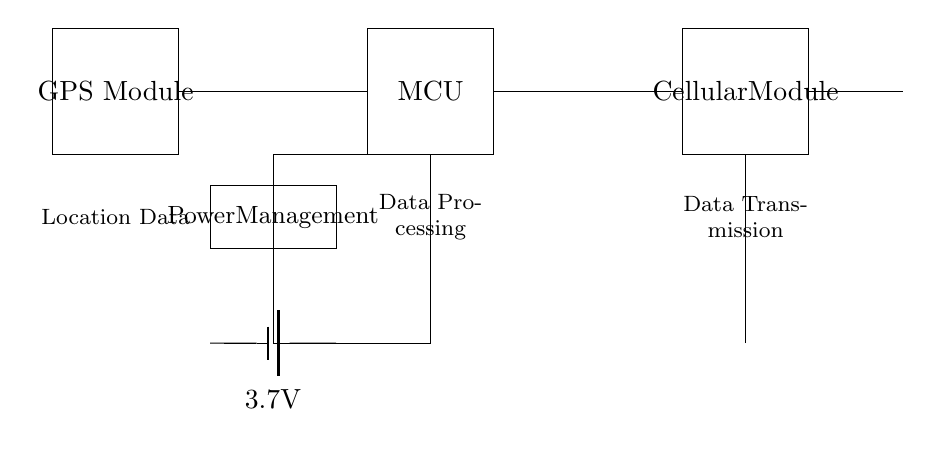What is the main purpose of the GPS module? The GPS module is responsible for acquiring location data by receiving signals from satellites, which allows it to determine the device's geographical position.
Answer: Location data What voltage does the battery supply? The battery is labeled with a voltage of 3.7 volts, indicating the potential difference it provides to the circuit.
Answer: 3.7 volts How many main components are in the diagram? There are four main components shown in the circuit: the GPS module, microcontroller, cellular module, and power management system.
Answer: Four What role does the microcontroller play in this circuit? The microcontroller processes the location data obtained from the GPS module and likely manages communication with the cellular module for data transmission.
Answer: Data processing Which component is responsible for data transmission? The cellular module is responsible for transmitting the processed location data to a remote server or monitoring system via cellular networks.
Answer: Cellular module What directly connects the GPS module and the microcontroller? A wire connection directly links the output of the GPS module to the input of the microcontroller, allowing data transfer between these two components.
Answer: A wire How does power management integrate into the circuit? The power management component regulates the supply voltage and current to the different modules in the device, ensuring stable operation and preventing damage to sensitive components.
Answer: Power management 